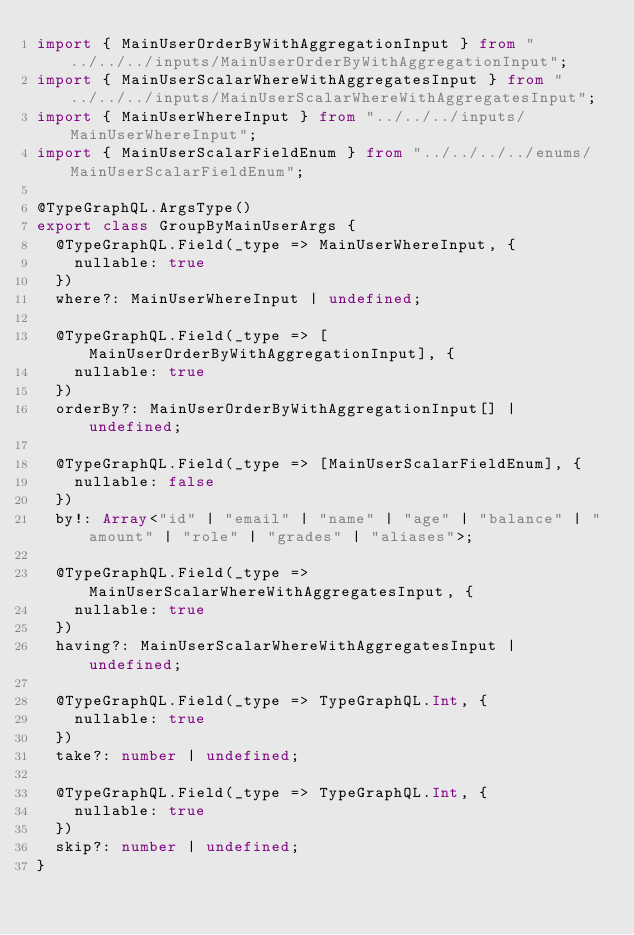Convert code to text. <code><loc_0><loc_0><loc_500><loc_500><_TypeScript_>import { MainUserOrderByWithAggregationInput } from "../../../inputs/MainUserOrderByWithAggregationInput";
import { MainUserScalarWhereWithAggregatesInput } from "../../../inputs/MainUserScalarWhereWithAggregatesInput";
import { MainUserWhereInput } from "../../../inputs/MainUserWhereInput";
import { MainUserScalarFieldEnum } from "../../../../enums/MainUserScalarFieldEnum";

@TypeGraphQL.ArgsType()
export class GroupByMainUserArgs {
  @TypeGraphQL.Field(_type => MainUserWhereInput, {
    nullable: true
  })
  where?: MainUserWhereInput | undefined;

  @TypeGraphQL.Field(_type => [MainUserOrderByWithAggregationInput], {
    nullable: true
  })
  orderBy?: MainUserOrderByWithAggregationInput[] | undefined;

  @TypeGraphQL.Field(_type => [MainUserScalarFieldEnum], {
    nullable: false
  })
  by!: Array<"id" | "email" | "name" | "age" | "balance" | "amount" | "role" | "grades" | "aliases">;

  @TypeGraphQL.Field(_type => MainUserScalarWhereWithAggregatesInput, {
    nullable: true
  })
  having?: MainUserScalarWhereWithAggregatesInput | undefined;

  @TypeGraphQL.Field(_type => TypeGraphQL.Int, {
    nullable: true
  })
  take?: number | undefined;

  @TypeGraphQL.Field(_type => TypeGraphQL.Int, {
    nullable: true
  })
  skip?: number | undefined;
}
</code> 